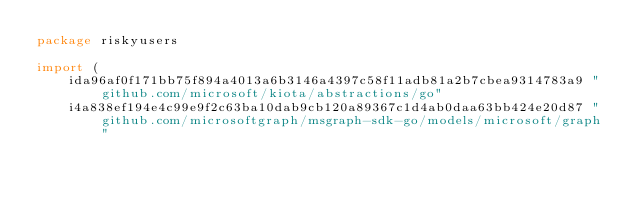<code> <loc_0><loc_0><loc_500><loc_500><_Go_>package riskyusers

import (
    ida96af0f171bb75f894a4013a6b3146a4397c58f11adb81a2b7cbea9314783a9 "github.com/microsoft/kiota/abstractions/go"
    i4a838ef194e4c99e9f2c63ba10dab9cb120a89367c1d4ab0daa63bb424e20d87 "github.com/microsoftgraph/msgraph-sdk-go/models/microsoft/graph"</code> 